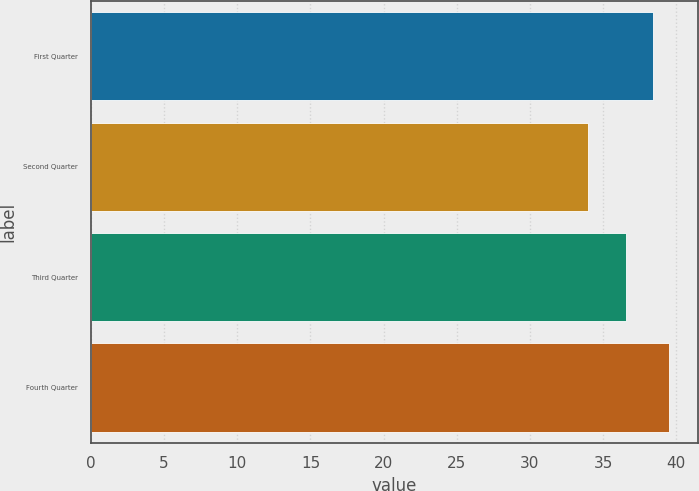Convert chart to OTSL. <chart><loc_0><loc_0><loc_500><loc_500><bar_chart><fcel>First Quarter<fcel>Second Quarter<fcel>Third Quarter<fcel>Fourth Quarter<nl><fcel>38.4<fcel>33.95<fcel>36.6<fcel>39.53<nl></chart> 